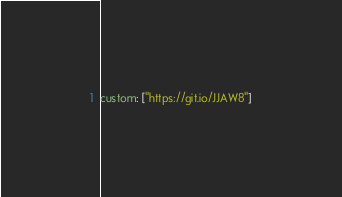<code> <loc_0><loc_0><loc_500><loc_500><_YAML_>custom: ["https://git.io/JJAW8"]
</code> 